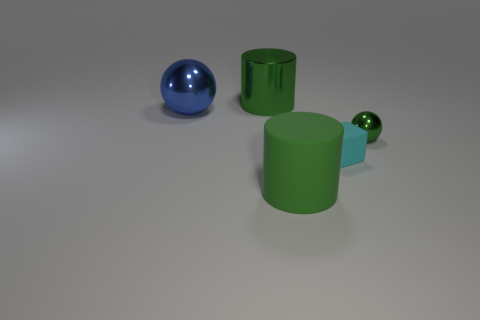Are there more small green objects to the left of the tiny shiny object than cyan matte things?
Keep it short and to the point. No. How many other objects are the same shape as the cyan thing?
Your response must be concise. 0. There is a green thing that is behind the big rubber thing and left of the tiny matte thing; what is it made of?
Offer a very short reply. Metal. How many things are either small green objects or tiny cyan blocks?
Keep it short and to the point. 2. Are there more tiny purple matte blocks than green balls?
Make the answer very short. No. There is a green cylinder that is in front of the object that is to the left of the big green metal object; what size is it?
Your answer should be very brief. Large. There is another tiny metallic thing that is the same shape as the blue thing; what is its color?
Ensure brevity in your answer.  Green. What is the size of the matte cylinder?
Your answer should be very brief. Large. What number of cylinders are either small cyan matte objects or blue objects?
Your answer should be compact. 0. There is a green metal thing that is the same shape as the blue metal thing; what size is it?
Keep it short and to the point. Small. 